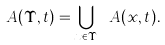<formula> <loc_0><loc_0><loc_500><loc_500>\ A ( \Upsilon , t ) = \bigcup _ { x \in \Upsilon } \ A ( x , t ) .</formula> 